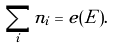<formula> <loc_0><loc_0><loc_500><loc_500>\sum _ { i } n _ { i } = e ( E ) .</formula> 